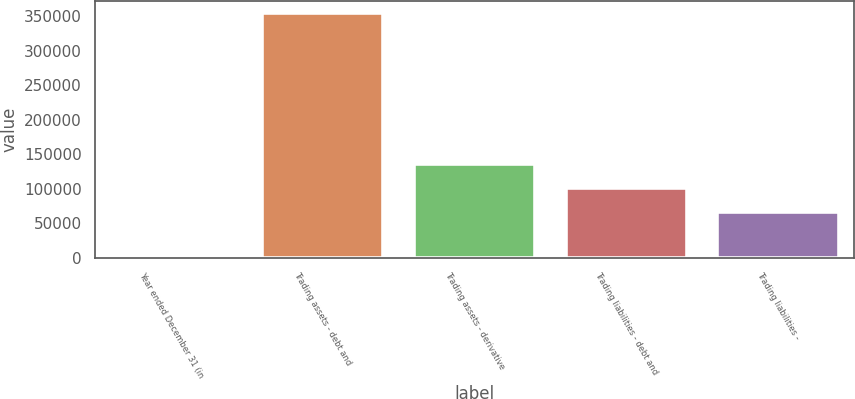Convert chart. <chart><loc_0><loc_0><loc_500><loc_500><bar_chart><fcel>Year ended December 31 (in<fcel>Trading assets - debt and<fcel>Trading assets - derivative<fcel>Trading liabilities - debt and<fcel>Trading liabilities -<nl><fcel>2010<fcel>354441<fcel>136200<fcel>100957<fcel>65714<nl></chart> 